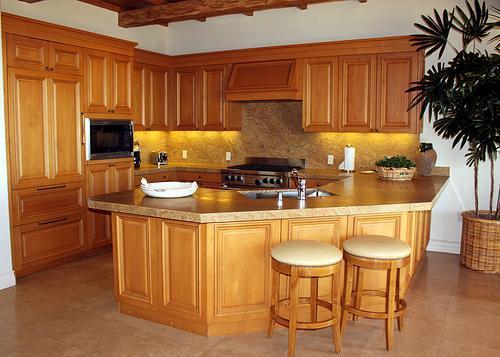How many chairs are there?
Give a very brief answer. 2. How many sinks are there?
Give a very brief answer. 1. How many plants are near the counter?
Give a very brief answer. 1. 